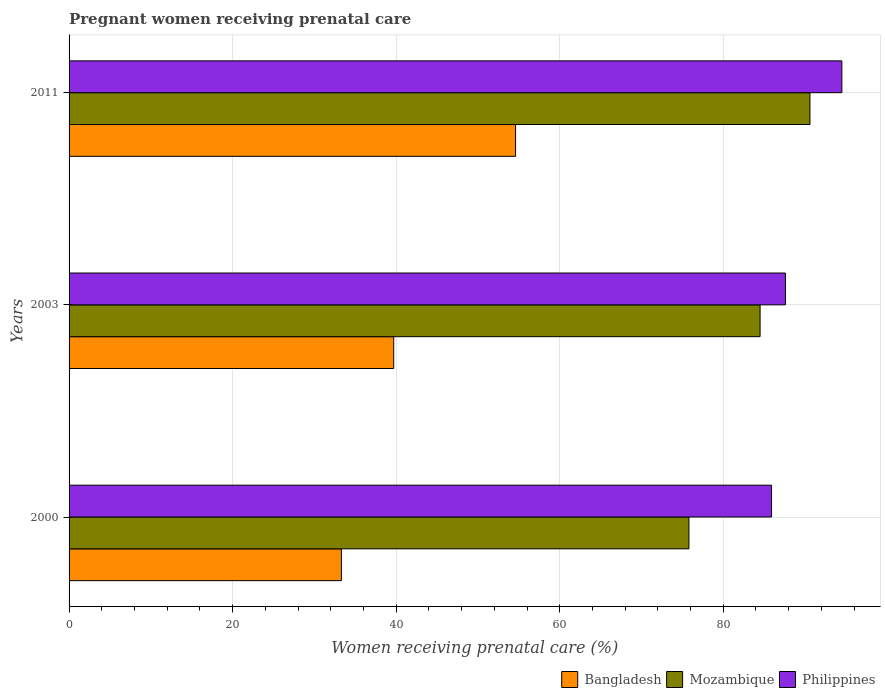Are the number of bars per tick equal to the number of legend labels?
Offer a very short reply. Yes. How many bars are there on the 2nd tick from the top?
Keep it short and to the point. 3. How many bars are there on the 3rd tick from the bottom?
Provide a short and direct response. 3. In how many cases, is the number of bars for a given year not equal to the number of legend labels?
Offer a very short reply. 0. What is the percentage of women receiving prenatal care in Bangladesh in 2000?
Make the answer very short. 33.3. Across all years, what is the maximum percentage of women receiving prenatal care in Mozambique?
Provide a succinct answer. 90.6. Across all years, what is the minimum percentage of women receiving prenatal care in Bangladesh?
Provide a short and direct response. 33.3. In which year was the percentage of women receiving prenatal care in Philippines maximum?
Your answer should be very brief. 2011. In which year was the percentage of women receiving prenatal care in Philippines minimum?
Offer a terse response. 2000. What is the total percentage of women receiving prenatal care in Mozambique in the graph?
Make the answer very short. 250.9. What is the difference between the percentage of women receiving prenatal care in Mozambique in 2000 and that in 2003?
Your response must be concise. -8.7. What is the difference between the percentage of women receiving prenatal care in Bangladesh in 2000 and the percentage of women receiving prenatal care in Philippines in 2011?
Make the answer very short. -61.2. What is the average percentage of women receiving prenatal care in Mozambique per year?
Provide a short and direct response. 83.63. In the year 2000, what is the difference between the percentage of women receiving prenatal care in Mozambique and percentage of women receiving prenatal care in Philippines?
Provide a succinct answer. -10.1. In how many years, is the percentage of women receiving prenatal care in Mozambique greater than 72 %?
Your response must be concise. 3. What is the ratio of the percentage of women receiving prenatal care in Mozambique in 2000 to that in 2011?
Give a very brief answer. 0.84. Is the percentage of women receiving prenatal care in Bangladesh in 2000 less than that in 2011?
Keep it short and to the point. Yes. What is the difference between the highest and the second highest percentage of women receiving prenatal care in Philippines?
Ensure brevity in your answer.  6.9. What is the difference between the highest and the lowest percentage of women receiving prenatal care in Mozambique?
Offer a terse response. 14.8. Is the sum of the percentage of women receiving prenatal care in Mozambique in 2003 and 2011 greater than the maximum percentage of women receiving prenatal care in Philippines across all years?
Give a very brief answer. Yes. What does the 3rd bar from the bottom in 2000 represents?
Your response must be concise. Philippines. How many bars are there?
Make the answer very short. 9. What is the difference between two consecutive major ticks on the X-axis?
Provide a succinct answer. 20. Are the values on the major ticks of X-axis written in scientific E-notation?
Provide a short and direct response. No. Does the graph contain any zero values?
Ensure brevity in your answer.  No. How many legend labels are there?
Provide a succinct answer. 3. What is the title of the graph?
Your answer should be very brief. Pregnant women receiving prenatal care. What is the label or title of the X-axis?
Your answer should be compact. Women receiving prenatal care (%). What is the label or title of the Y-axis?
Make the answer very short. Years. What is the Women receiving prenatal care (%) in Bangladesh in 2000?
Your answer should be compact. 33.3. What is the Women receiving prenatal care (%) in Mozambique in 2000?
Your answer should be very brief. 75.8. What is the Women receiving prenatal care (%) of Philippines in 2000?
Make the answer very short. 85.9. What is the Women receiving prenatal care (%) of Bangladesh in 2003?
Make the answer very short. 39.7. What is the Women receiving prenatal care (%) in Mozambique in 2003?
Provide a short and direct response. 84.5. What is the Women receiving prenatal care (%) in Philippines in 2003?
Make the answer very short. 87.6. What is the Women receiving prenatal care (%) of Bangladesh in 2011?
Your response must be concise. 54.6. What is the Women receiving prenatal care (%) in Mozambique in 2011?
Give a very brief answer. 90.6. What is the Women receiving prenatal care (%) of Philippines in 2011?
Provide a succinct answer. 94.5. Across all years, what is the maximum Women receiving prenatal care (%) of Bangladesh?
Ensure brevity in your answer.  54.6. Across all years, what is the maximum Women receiving prenatal care (%) of Mozambique?
Keep it short and to the point. 90.6. Across all years, what is the maximum Women receiving prenatal care (%) in Philippines?
Offer a terse response. 94.5. Across all years, what is the minimum Women receiving prenatal care (%) of Bangladesh?
Offer a terse response. 33.3. Across all years, what is the minimum Women receiving prenatal care (%) in Mozambique?
Offer a terse response. 75.8. Across all years, what is the minimum Women receiving prenatal care (%) in Philippines?
Make the answer very short. 85.9. What is the total Women receiving prenatal care (%) in Bangladesh in the graph?
Keep it short and to the point. 127.6. What is the total Women receiving prenatal care (%) in Mozambique in the graph?
Provide a succinct answer. 250.9. What is the total Women receiving prenatal care (%) of Philippines in the graph?
Provide a succinct answer. 268. What is the difference between the Women receiving prenatal care (%) in Bangladesh in 2000 and that in 2011?
Give a very brief answer. -21.3. What is the difference between the Women receiving prenatal care (%) of Mozambique in 2000 and that in 2011?
Give a very brief answer. -14.8. What is the difference between the Women receiving prenatal care (%) of Bangladesh in 2003 and that in 2011?
Provide a succinct answer. -14.9. What is the difference between the Women receiving prenatal care (%) of Bangladesh in 2000 and the Women receiving prenatal care (%) of Mozambique in 2003?
Ensure brevity in your answer.  -51.2. What is the difference between the Women receiving prenatal care (%) in Bangladesh in 2000 and the Women receiving prenatal care (%) in Philippines in 2003?
Provide a succinct answer. -54.3. What is the difference between the Women receiving prenatal care (%) of Bangladesh in 2000 and the Women receiving prenatal care (%) of Mozambique in 2011?
Offer a terse response. -57.3. What is the difference between the Women receiving prenatal care (%) of Bangladesh in 2000 and the Women receiving prenatal care (%) of Philippines in 2011?
Keep it short and to the point. -61.2. What is the difference between the Women receiving prenatal care (%) of Mozambique in 2000 and the Women receiving prenatal care (%) of Philippines in 2011?
Provide a short and direct response. -18.7. What is the difference between the Women receiving prenatal care (%) of Bangladesh in 2003 and the Women receiving prenatal care (%) of Mozambique in 2011?
Give a very brief answer. -50.9. What is the difference between the Women receiving prenatal care (%) of Bangladesh in 2003 and the Women receiving prenatal care (%) of Philippines in 2011?
Your answer should be very brief. -54.8. What is the average Women receiving prenatal care (%) of Bangladesh per year?
Your answer should be very brief. 42.53. What is the average Women receiving prenatal care (%) of Mozambique per year?
Provide a succinct answer. 83.63. What is the average Women receiving prenatal care (%) of Philippines per year?
Your response must be concise. 89.33. In the year 2000, what is the difference between the Women receiving prenatal care (%) in Bangladesh and Women receiving prenatal care (%) in Mozambique?
Make the answer very short. -42.5. In the year 2000, what is the difference between the Women receiving prenatal care (%) of Bangladesh and Women receiving prenatal care (%) of Philippines?
Give a very brief answer. -52.6. In the year 2000, what is the difference between the Women receiving prenatal care (%) of Mozambique and Women receiving prenatal care (%) of Philippines?
Keep it short and to the point. -10.1. In the year 2003, what is the difference between the Women receiving prenatal care (%) of Bangladesh and Women receiving prenatal care (%) of Mozambique?
Your answer should be compact. -44.8. In the year 2003, what is the difference between the Women receiving prenatal care (%) in Bangladesh and Women receiving prenatal care (%) in Philippines?
Ensure brevity in your answer.  -47.9. In the year 2011, what is the difference between the Women receiving prenatal care (%) of Bangladesh and Women receiving prenatal care (%) of Mozambique?
Give a very brief answer. -36. In the year 2011, what is the difference between the Women receiving prenatal care (%) in Bangladesh and Women receiving prenatal care (%) in Philippines?
Give a very brief answer. -39.9. In the year 2011, what is the difference between the Women receiving prenatal care (%) of Mozambique and Women receiving prenatal care (%) of Philippines?
Make the answer very short. -3.9. What is the ratio of the Women receiving prenatal care (%) in Bangladesh in 2000 to that in 2003?
Give a very brief answer. 0.84. What is the ratio of the Women receiving prenatal care (%) in Mozambique in 2000 to that in 2003?
Keep it short and to the point. 0.9. What is the ratio of the Women receiving prenatal care (%) of Philippines in 2000 to that in 2003?
Keep it short and to the point. 0.98. What is the ratio of the Women receiving prenatal care (%) of Bangladesh in 2000 to that in 2011?
Keep it short and to the point. 0.61. What is the ratio of the Women receiving prenatal care (%) of Mozambique in 2000 to that in 2011?
Ensure brevity in your answer.  0.84. What is the ratio of the Women receiving prenatal care (%) of Philippines in 2000 to that in 2011?
Provide a short and direct response. 0.91. What is the ratio of the Women receiving prenatal care (%) of Bangladesh in 2003 to that in 2011?
Give a very brief answer. 0.73. What is the ratio of the Women receiving prenatal care (%) of Mozambique in 2003 to that in 2011?
Ensure brevity in your answer.  0.93. What is the ratio of the Women receiving prenatal care (%) in Philippines in 2003 to that in 2011?
Your response must be concise. 0.93. What is the difference between the highest and the second highest Women receiving prenatal care (%) of Philippines?
Offer a very short reply. 6.9. What is the difference between the highest and the lowest Women receiving prenatal care (%) of Bangladesh?
Give a very brief answer. 21.3. What is the difference between the highest and the lowest Women receiving prenatal care (%) of Philippines?
Offer a terse response. 8.6. 